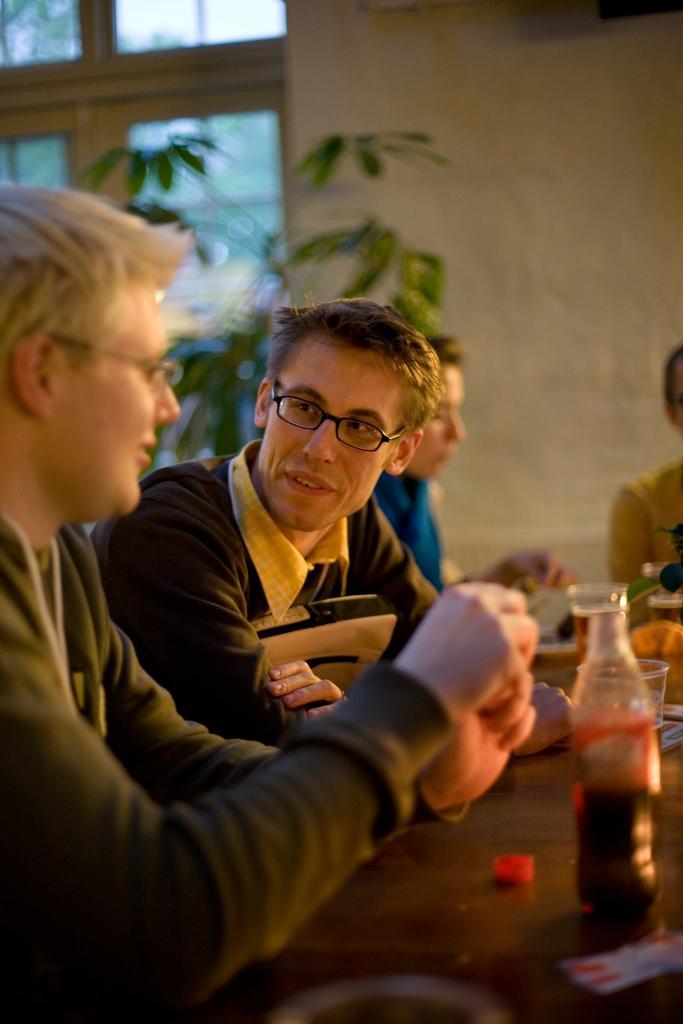Describe this image in one or two sentences. Here we can see persons. They have spectacles. This is table. On the table there is a bottle and glasses. On the background there is a wall and this is plant. 